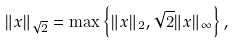Convert formula to latex. <formula><loc_0><loc_0><loc_500><loc_500>\| x \| _ { \sqrt { 2 } } = \max \left \{ \| x \| _ { 2 } , \sqrt { 2 } \| x \| _ { \infty } \right \} ,</formula> 